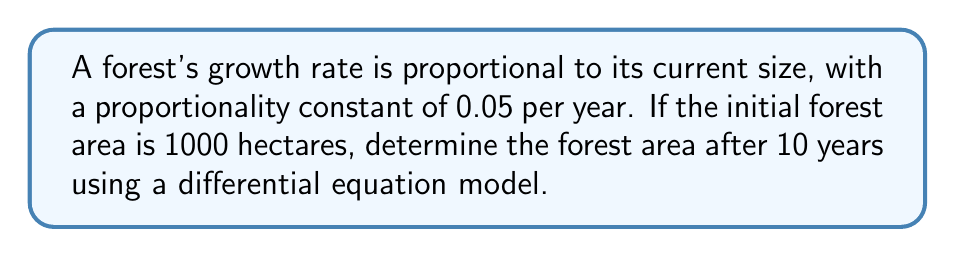Give your solution to this math problem. Let's approach this step-by-step:

1) Let $A(t)$ be the forest area in hectares at time $t$ in years.

2) The growth rate is proportional to the current size, so we can express this as a differential equation:

   $$\frac{dA}{dt} = 0.05A$$

3) This is a separable differential equation. We can solve it as follows:

   $$\frac{dA}{A} = 0.05dt$$

4) Integrating both sides:

   $$\int \frac{dA}{A} = \int 0.05dt$$

   $$\ln|A| = 0.05t + C$$

5) Solving for $A$:

   $$A = e^{0.05t + C} = e^C \cdot e^{0.05t}$$

6) Let $A_0 = e^C$ be the initial forest area. We're given that $A_0 = 1000$ hectares.

7) So our solution is:

   $$A(t) = 1000 \cdot e^{0.05t}$$

8) To find the area after 10 years, we substitute $t = 10$:

   $$A(10) = 1000 \cdot e^{0.05 \cdot 10} = 1000 \cdot e^{0.5} \approx 1648.72$$

Therefore, after 10 years, the forest area will be approximately 1648.72 hectares.
Answer: 1648.72 hectares 